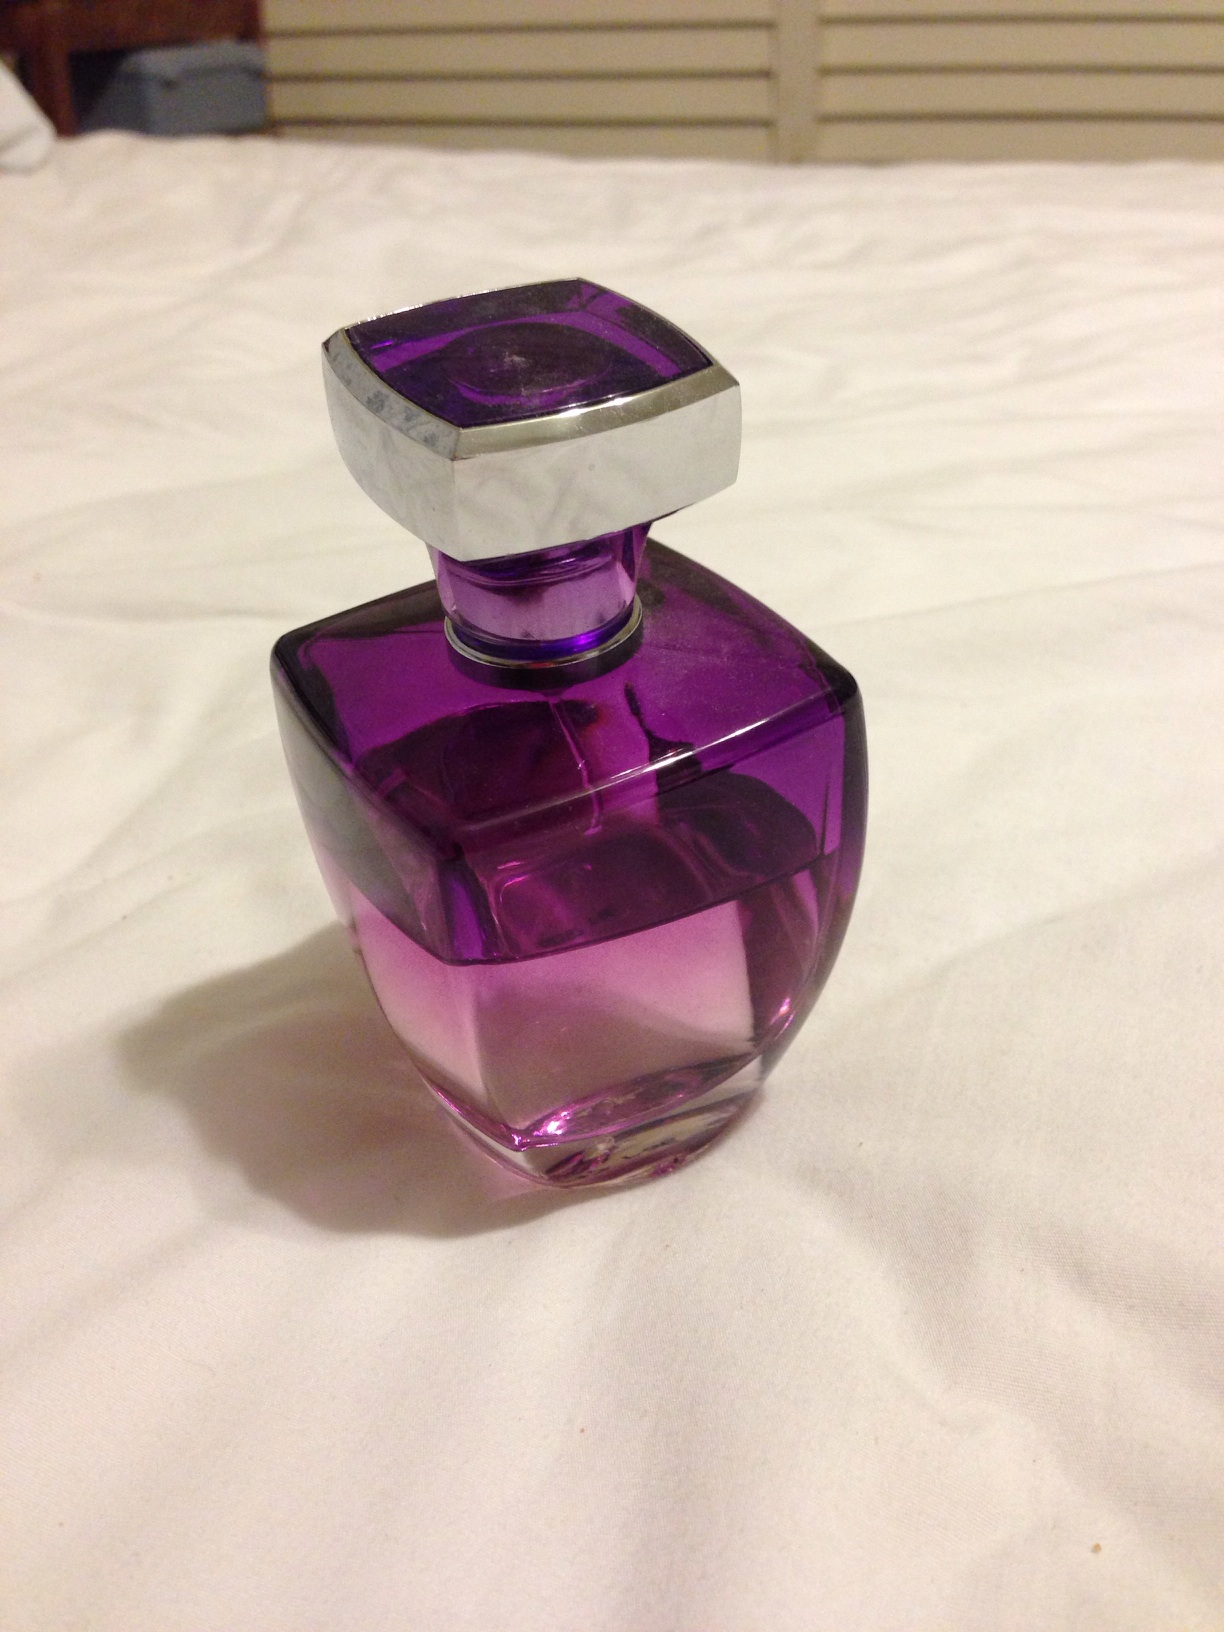Could you speculate on the target audience for this perfume based on the design? The perfume's design suggests that it may be targeting a demographic that appreciates modern elegance and boldness. It seems to cater to those who are fashion-forward and might enjoy fragrances that make a statement, potentially skewing towards a younger, trend-setting audience. 